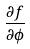Convert formula to latex. <formula><loc_0><loc_0><loc_500><loc_500>\frac { \partial f } { \partial \phi }</formula> 